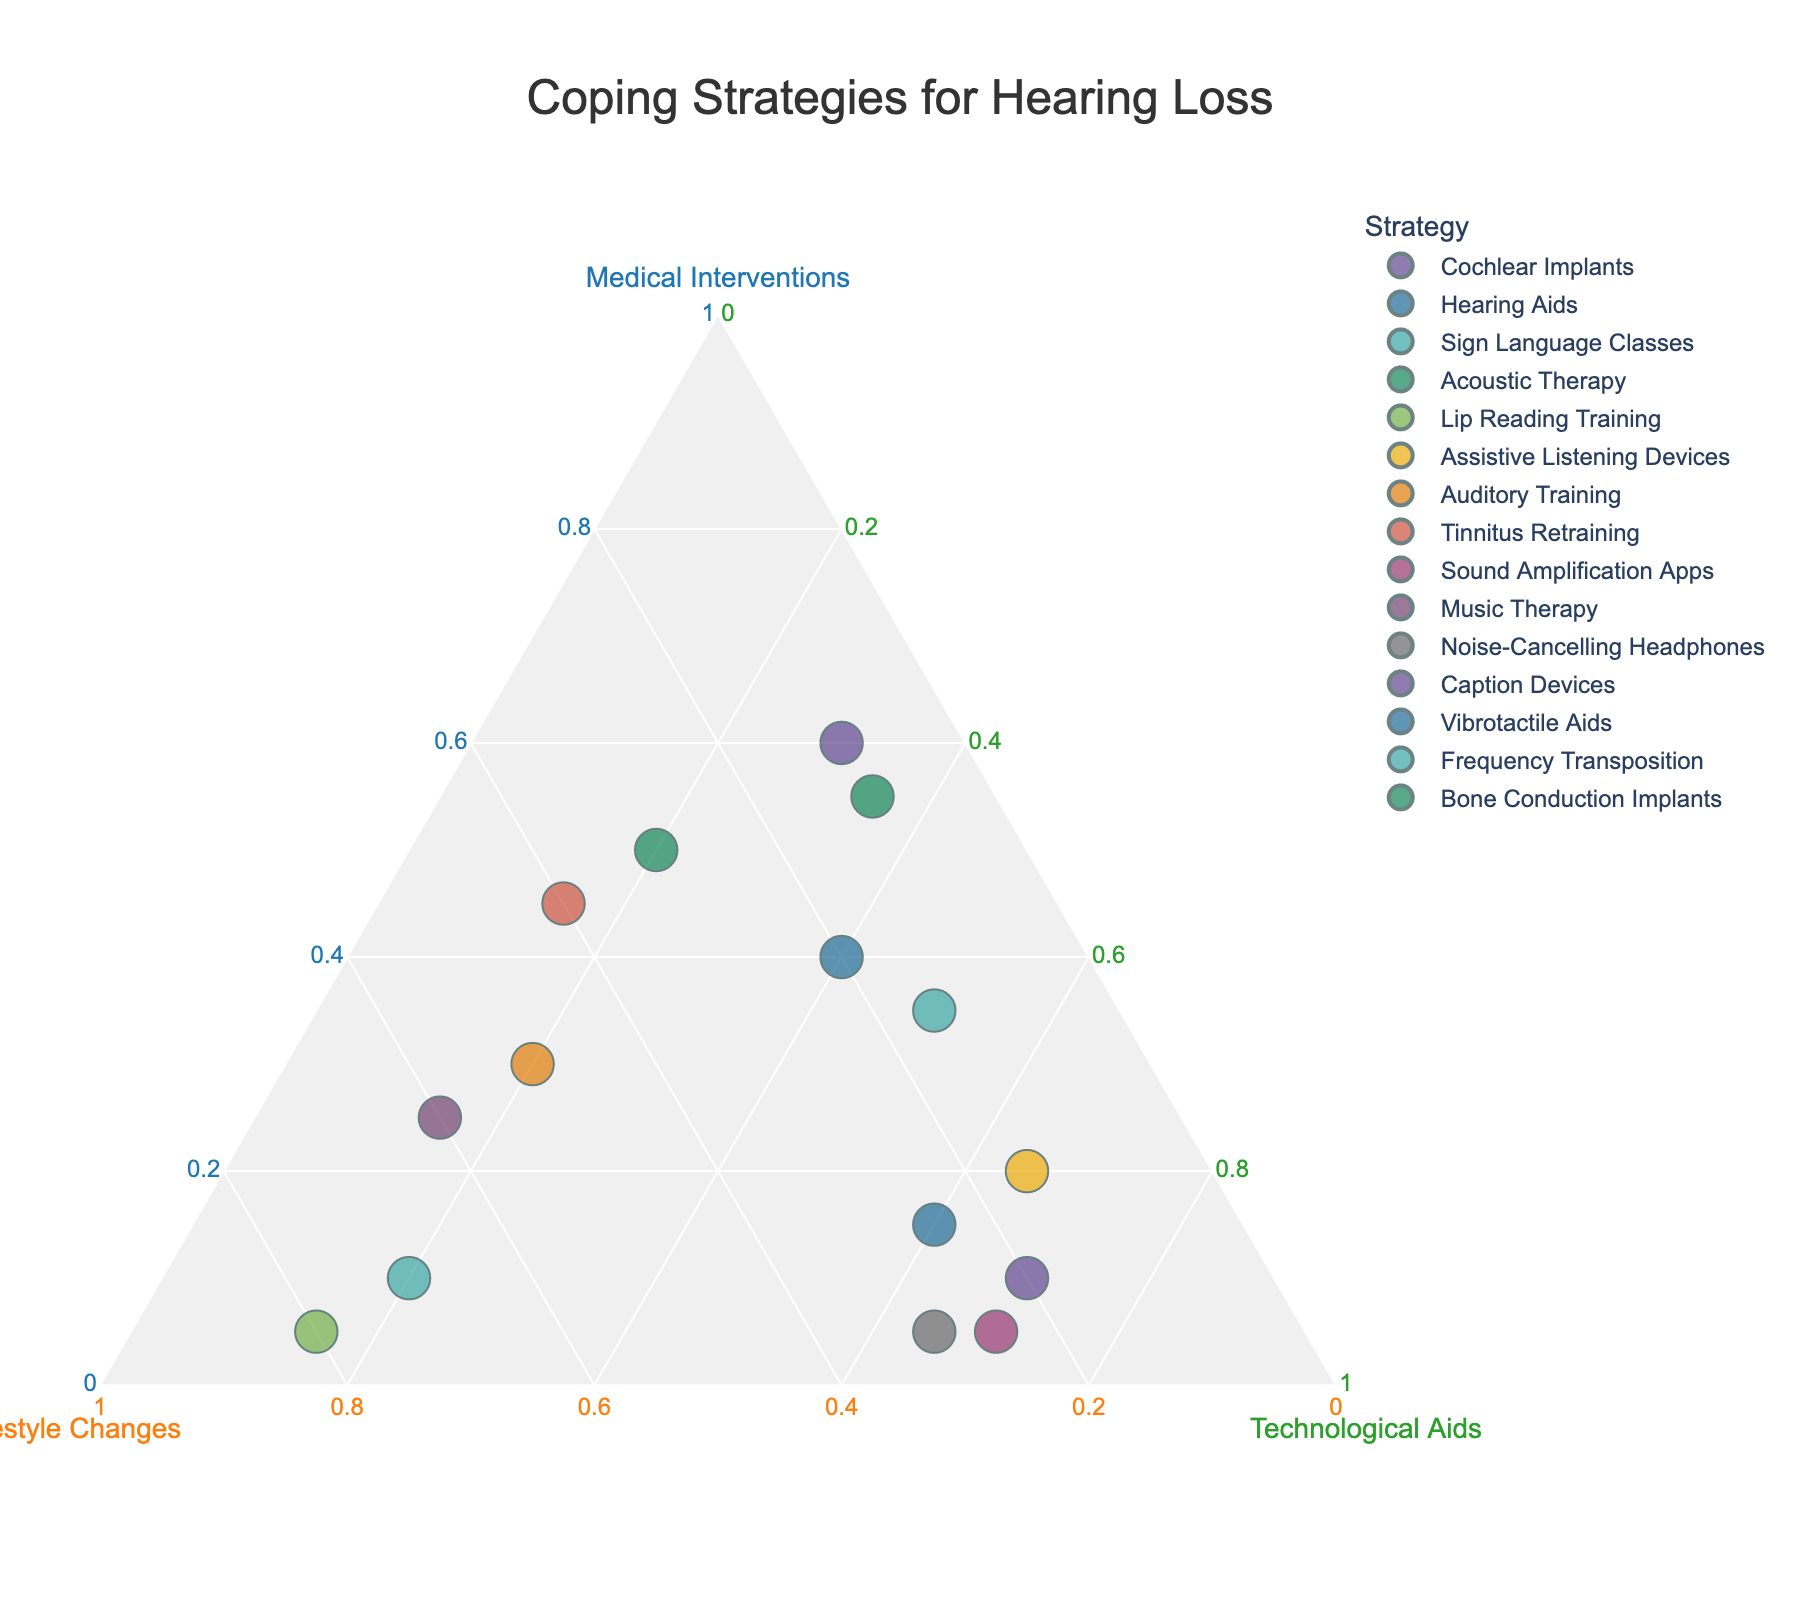What is the title of the plot? The title of the plot is usually placed at the top of the figure for easy identification. Here, the title states the main subject of the visual representation.
Answer: Coping Strategies for Hearing Loss What strategy has the highest percentage of Medical Interventions? To find the strategy with the highest percentage of Medical Interventions, look at the axis or section labeled "Medical Interventions" and identify the data point that is the furthest along this axis.
Answer: Cochlear Implants Which strategy relies the most on Lifestyle Changes? Identify the strategy located closest to the axis labeled "Lifestyle Changes." This represents the strategy with the highest reliance on lifestyle changes.
Answer: Lip Reading Training What strategy has an equal distribution between Medical Interventions and Technological Aids? Look for the data point positioned such that its coordinates for Medical Interventions and Technological Aids are the same.
Answer: Hearing Aids Which strategy is positioned closer to Technological Aids than to the other two categories? Examine the data points and find the one closest to the axis representing Technological Aids, indicating a higher percentage for that category.
Answer: Caption Devices How many strategies have Medical Interventions greater than 50%? Count all the strategies that have a Medical Interventions percentage greater than 50%. These points will be closer to the Medical Interventions axis.
Answer: 3 Which two strategies are closest together on the plot? Look for data points that are positioned next to each other with minimal distance between them.
Answer: Vibrotactile Aids and Noise-Cancelling Headphones Which strategy is closest to the center of the plot? Find the data point that is positioned nearest to the center of the ternary plot, indicating a more balanced contribution from all three categories.
Answer: Acoustic Therapy 